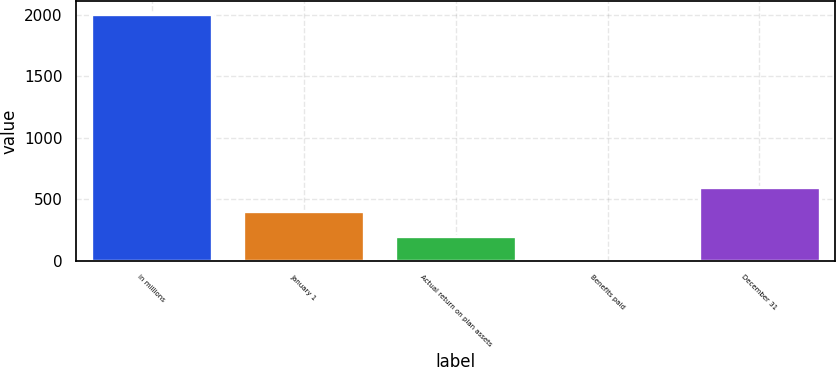<chart> <loc_0><loc_0><loc_500><loc_500><bar_chart><fcel>in millions<fcel>January 1<fcel>Actual return on plan assets<fcel>Benefits paid<fcel>December 31<nl><fcel>2009<fcel>402.12<fcel>201.26<fcel>0.4<fcel>602.98<nl></chart> 